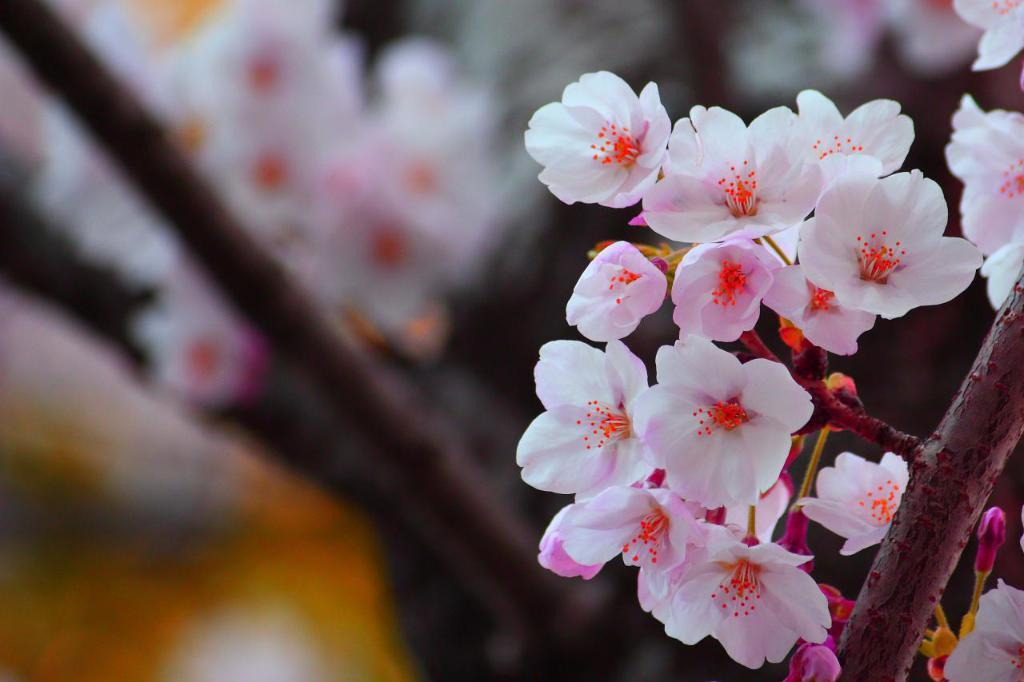What is the main subject of the image? The main subject of the image is a group of flowers. What can be seen extending from the flowers in the image? There are stems visible in the image. Can you describe the background of the image? The background of the image is blurred. What type of shoe can be seen in the image? There is no shoe present in the image; it features a group of flowers with stems and a blurred background. 